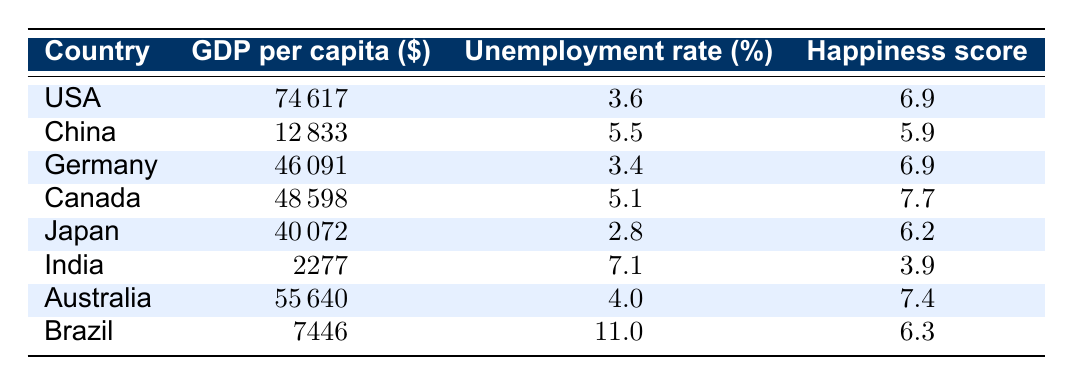What is the GDP per capita of Canada? The table lists the GDP per capita of Canada as 48598.
Answer: 48598 Which country has the highest happiness score? The table indicates the happiness scores of several countries. The highest score listed is 7.7 for Canada.
Answer: Canada Is the unemployment rate of Japan lower than that of Germany? The unemployment rate for Japan is 2.8%, while for Germany it is 3.4%. Since 2.8 is less than 3.4, the statement is true.
Answer: Yes Calculate the average GDP per capita of the countries in the table. The GDP per capita values are 74617, 12833, 46091, 48598, 40072, 2277, 55640, and 7446. Adding these values (74617 + 12833 + 46091 + 48598 + 40072 + 2277 + 55640 + 7446) gives 188,174. There are 8 countries, so the average is 188,174 / 8 = 23,521.75.
Answer: 23521.75 Is there a country with a GDP per capita greater than 70,000? The table shows GDP per capita values for all listed countries, and the highest value is 74617 for the USA, which is less than 70000. Therefore, there is no country with a GDP per capita greater than 70,000.
Answer: No How many countries have a happiness score below 6? The happiness scores for all countries are 6.9, 5.9, 6.9, 7.7, 6.2, 3.9, 7.4, and 6.3. The only score below 6 is 3.9 for India. Thus, only one country has a happiness score below 6.
Answer: 1 Which country has the highest unemployment rate? Looking through the unemployment rates, Brazil has the highest rate at 11.0%. Thus, Brazil has the highest unemployment rate among the listed countries.
Answer: Brazil If we combined the happiness scores of India and China, what would the total be? The happiness score for India is 3.9 and for China it is 5.9. Adding these scores together (3.9 + 5.9) gives a total of 9.8.
Answer: 9.8 